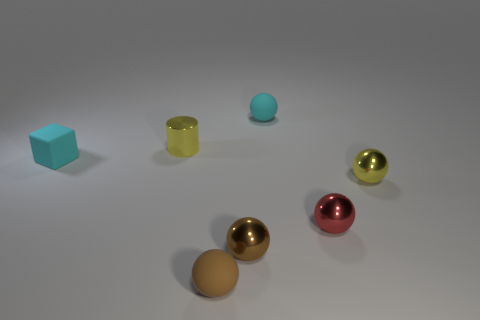Subtract all cyan spheres. How many spheres are left? 4 Subtract all tiny red spheres. How many spheres are left? 4 Subtract all purple spheres. Subtract all cyan cylinders. How many spheres are left? 5 Add 1 brown metal spheres. How many objects exist? 8 Subtract all spheres. How many objects are left? 2 Add 7 cyan objects. How many cyan objects exist? 9 Subtract 0 gray cylinders. How many objects are left? 7 Subtract all purple matte objects. Subtract all yellow metal cylinders. How many objects are left? 6 Add 7 matte balls. How many matte balls are left? 9 